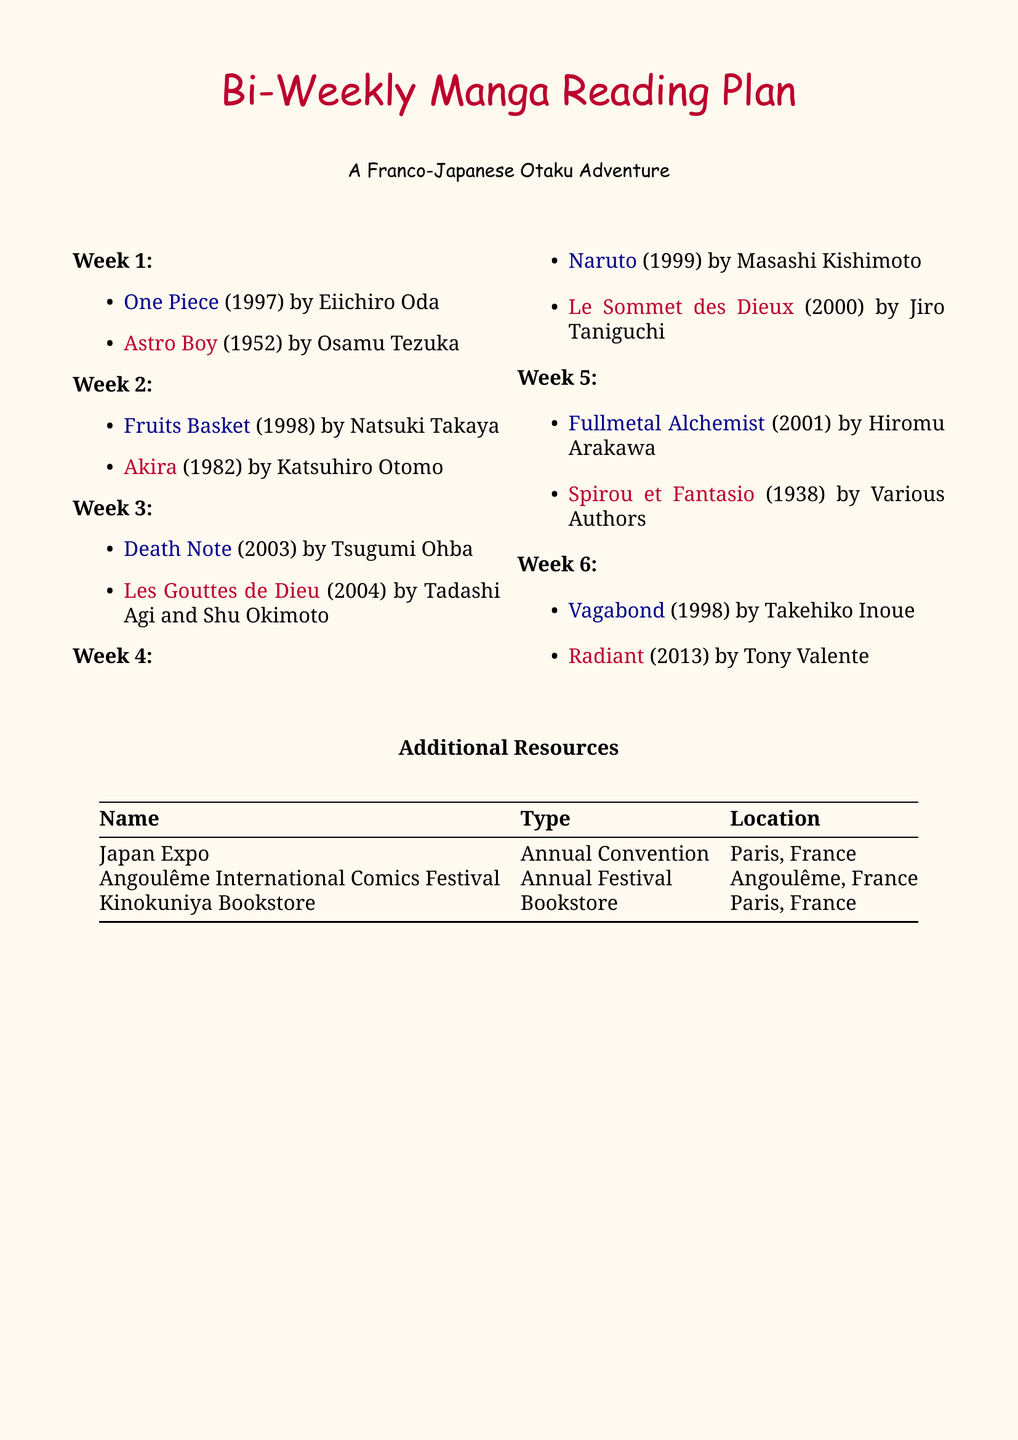What is the genre of "Death Note"? The genre of "Death Note" is listed in the document as "Mystery Thriller".
Answer: Mystery Thriller Who is the author of "Fruits Basket"? The author of "Fruits Basket" is provided in the document as Natsuki Takaya.
Answer: Natsuki Takaya In which year was "Akira" published? The publication year of "Akira" can be found in the document as 1982.
Answer: 1982 How many weeks are included in the manga reading plan? The document outlines a bi-weekly reading plan covering 6 weeks.
Answer: 6 Which title combines French wine culture with Japanese manga style? The title that combines French wine culture with Japanese manga style is "Les Gouttes de Dieu".
Answer: Les Gouttes de Dieu What type of resource is Japan Expo? Japan Expo is categorized in the document as an "Annual Convention".
Answer: Annual Convention Which manga is described as "well-received by French manga enthusiasts"? The manga described as "well-received by French manga enthusiasts" is "Fullmetal Alchemist".
Answer: Fullmetal Alchemist Which week features two titles by different authors? Week 5 features "Fullmetal Alchemist" by Hiromu Arakawa and "Spirou et Fantasio" by Various Authors.
Answer: Week 5 What city hosts the Kinokuniya Bookstore? The document states that Kinokuniya Bookstore is located in Paris, France.
Answer: Paris, France 